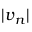<formula> <loc_0><loc_0><loc_500><loc_500>| \boldsymbol v _ { n } |</formula> 